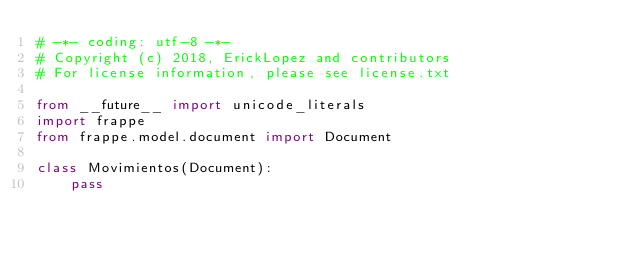Convert code to text. <code><loc_0><loc_0><loc_500><loc_500><_Python_># -*- coding: utf-8 -*-
# Copyright (c) 2018, ErickLopez and contributors
# For license information, please see license.txt

from __future__ import unicode_literals
import frappe
from frappe.model.document import Document

class Movimientos(Document):
	pass
</code> 